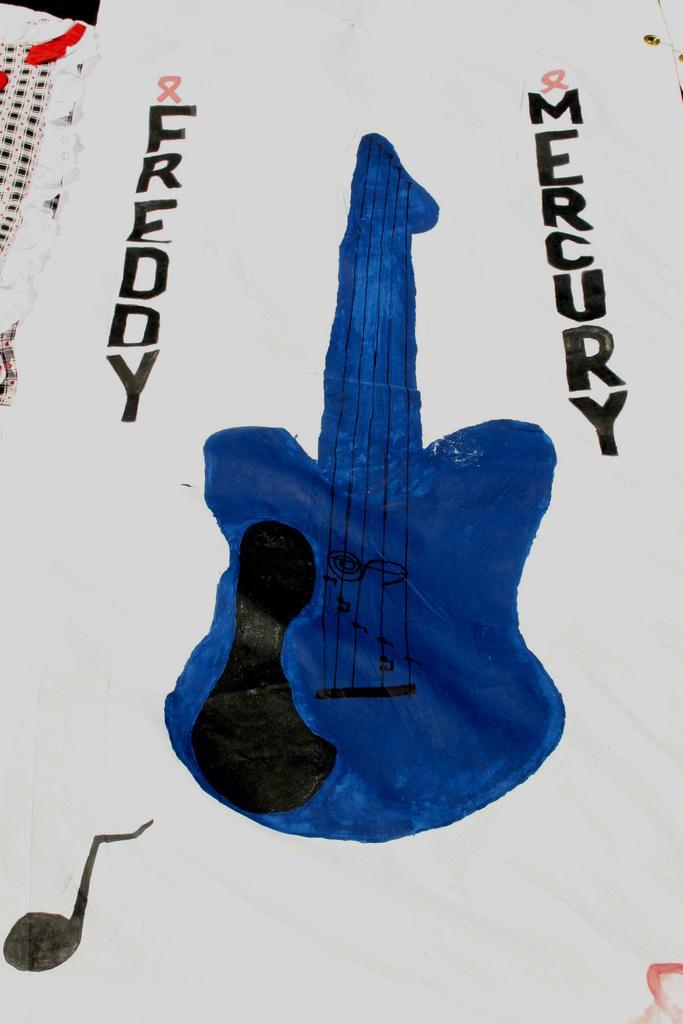Could you give a brief overview of what you see in this image? In this image, we can see a painting of a guitar in blue color. 